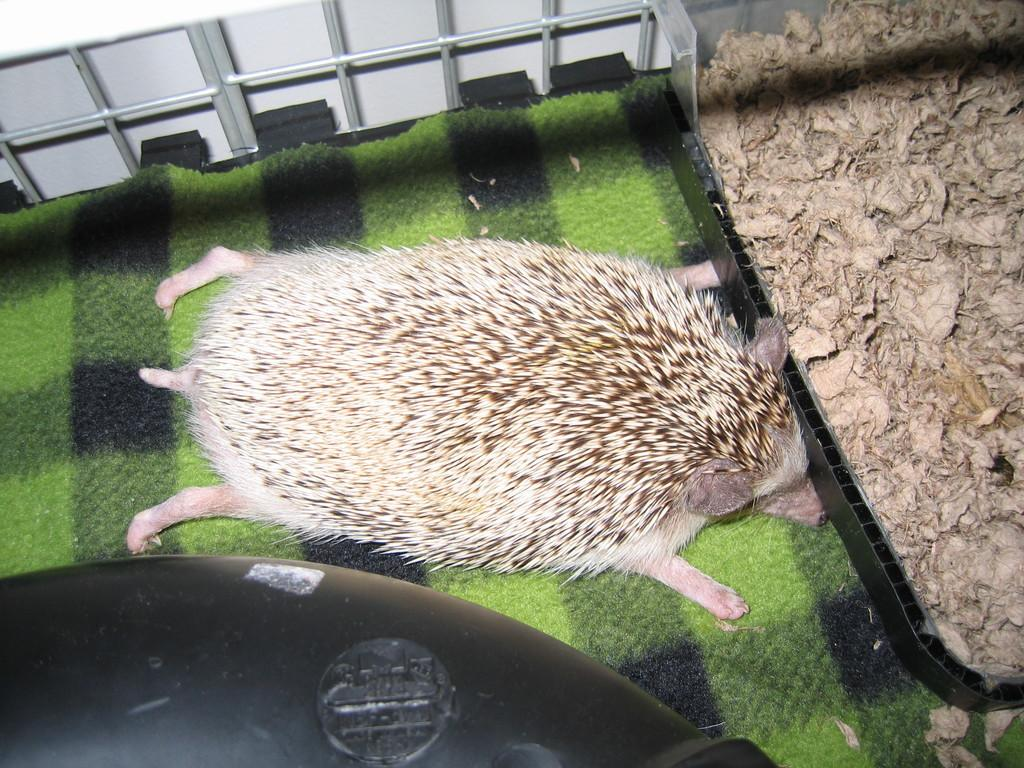What type of animal can be seen in the image? There is an animal in the image, but its specific type cannot be determined from the provided facts. What is the animal resting on or standing on? The animal is on a surface in the image. What can be seen on the right side of the image? There are dried leaves on the right side of the image. What is visible at the top of the image? There is a wall visible at the top of the image. What type of enclosure is present in the image? There is a metal cage in the image. What is the color of the object at the bottom of the image? The object at the bottom of the image is black. How does the wind affect the level of the animal's shame in the image? There is no mention of wind, level, or shame in the image, so this question cannot be answered definitively. 